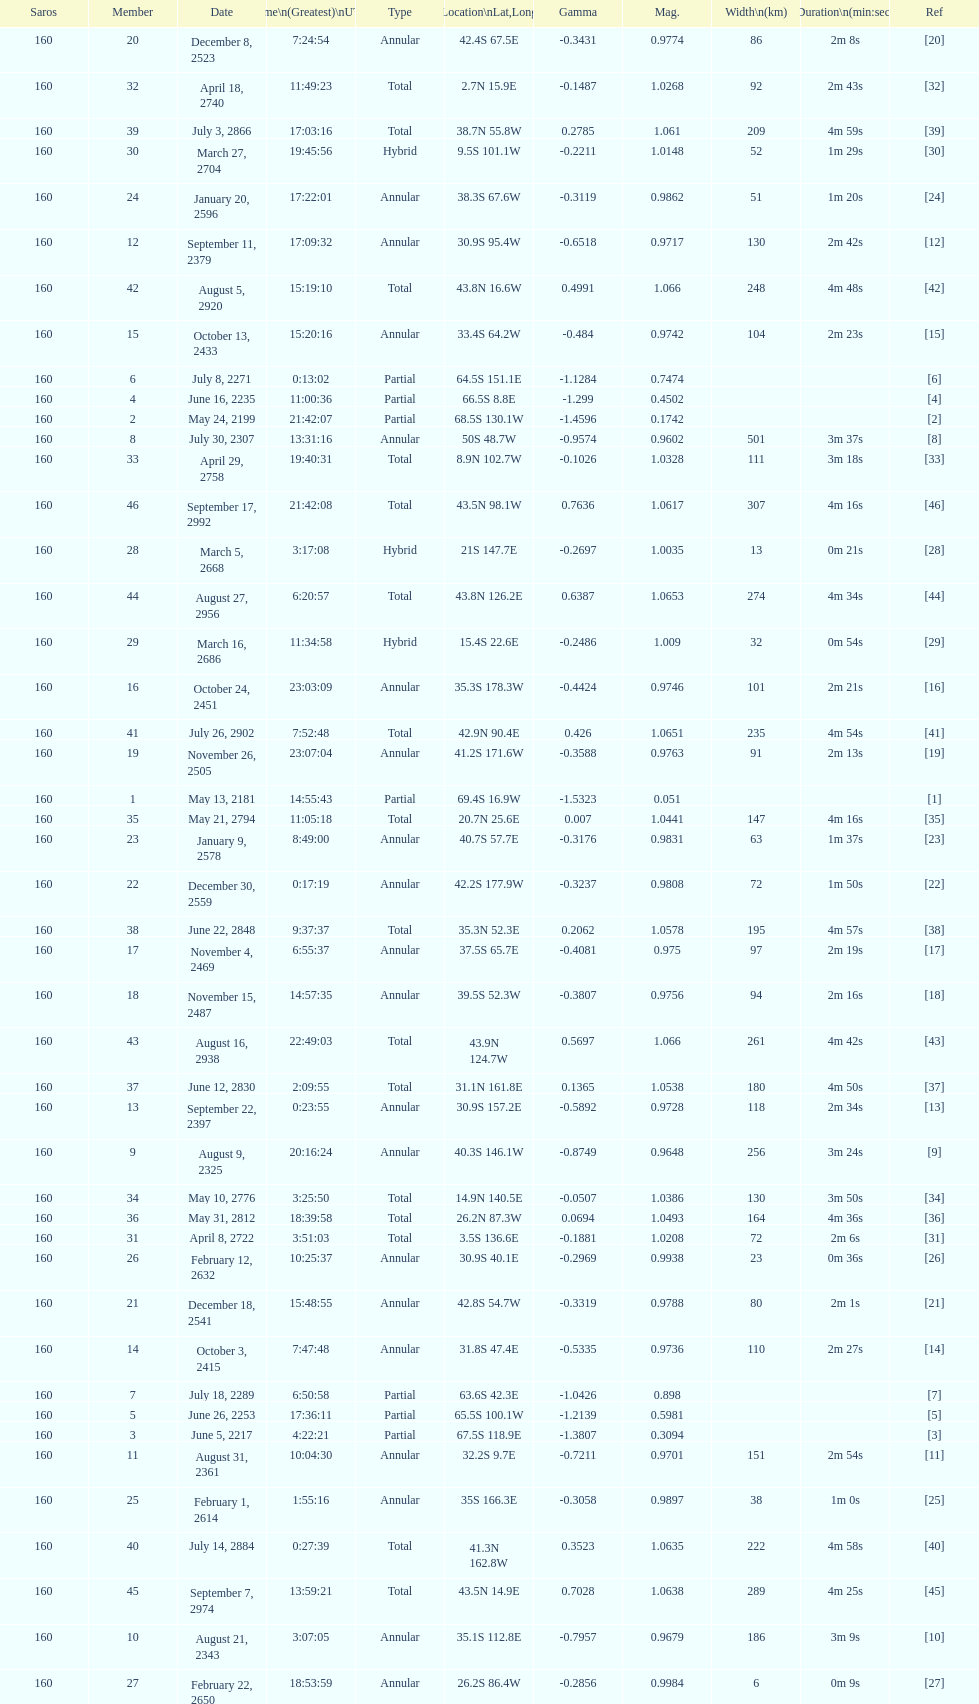How long did the the saros on july 30, 2307 last for? 3m 37s. 